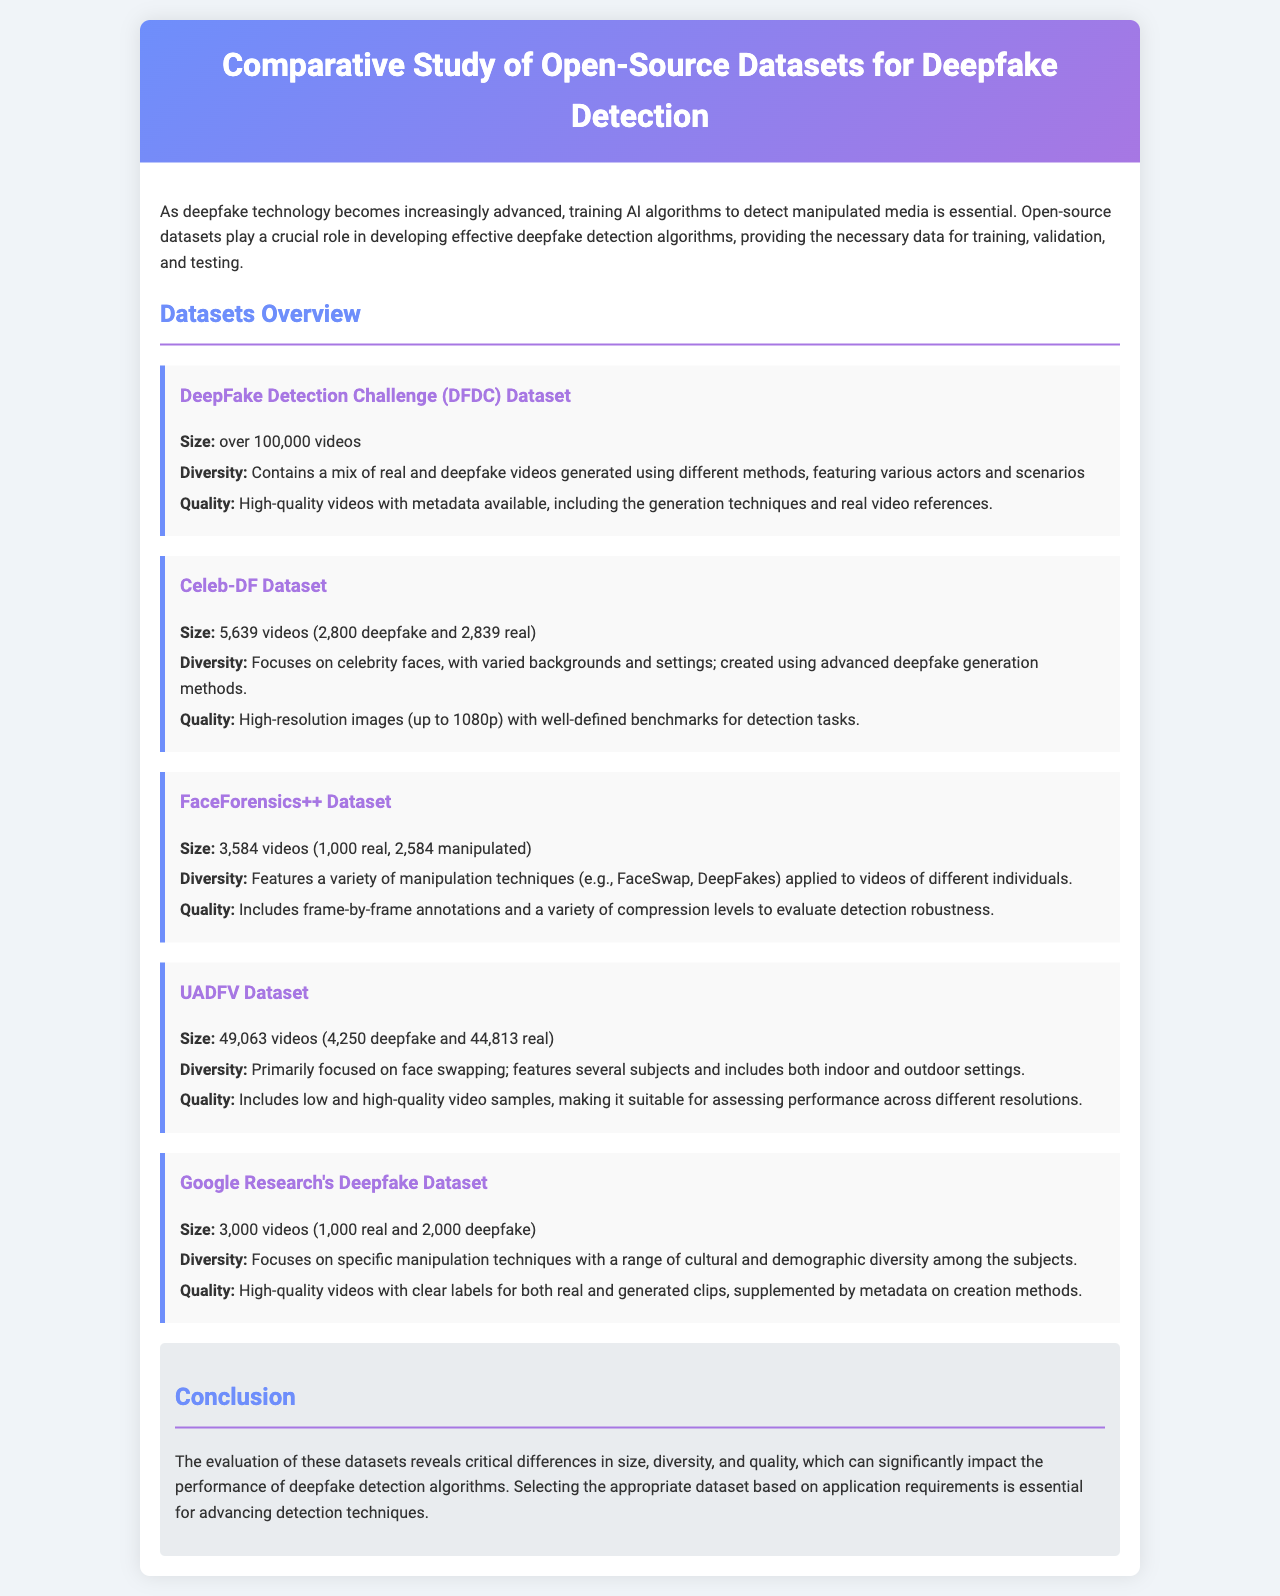what is the size of the DeepFake Detection Challenge (DFDC) Dataset? The size of the DFDC dataset is specified as being over 100,000 videos.
Answer: over 100,000 videos how many videos are in the Celeb-DF Dataset? The Celeb-DF dataset consists of a total of 5,639 videos, which includes both deepfakes and real videos.
Answer: 5,639 videos what manipulation techniques does the FaceForensics++ Dataset include? The FaceForensics++ Dataset features a variety of manipulation techniques, specifically mentioning FaceSwap and DeepFakes.
Answer: FaceSwap, DeepFakes what is the primary focus of the UADFV Dataset? The UADFV Dataset is primarily focused on face swapping, which is indicated in the diversity description.
Answer: face swapping how many videos are real in the Google Research's Deepfake Dataset? The total number of real videos in Google Research's Deepfake Dataset is 1,000.
Answer: 1,000 which dataset has high-resolution images up to 1080p? The Celeb-DF Dataset is noted for having high-resolution images with a resolution up to 1080p.
Answer: Celeb-DF Dataset what type of annotations does the FaceForensics++ Dataset include? The FaceForensics++ Dataset includes frame-by-frame annotations, helping to evaluate detection robustness.
Answer: frame-by-frame annotations which dataset contains videos generated using different methods? The DeepFake Detection Challenge (DFDC) Dataset contains videos generated using different methods, enhancing its diversity.
Answer: DeepFake Detection Challenge (DFDC) Dataset what factor is essential for advancing detection techniques according to the conclusion? The conclusion emphasizes that selecting the appropriate dataset based on application requirements is essential for advancing detection techniques.
Answer: appropriate dataset based on application requirements 